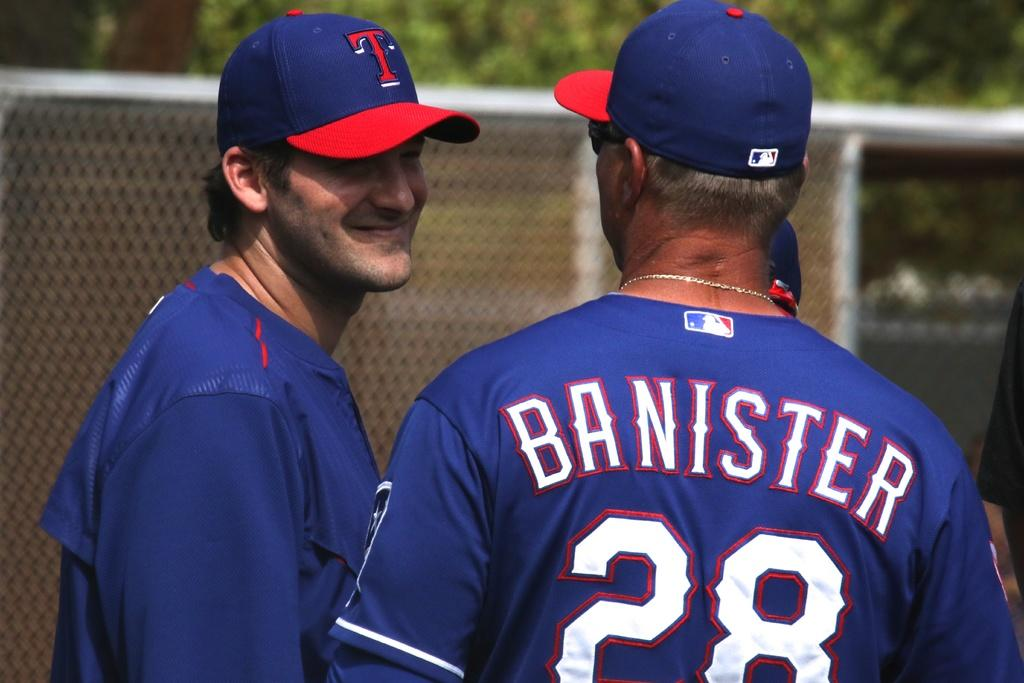<image>
Provide a brief description of the given image. Two baseball players talk to eachother, Banister is talking to his teammate. 